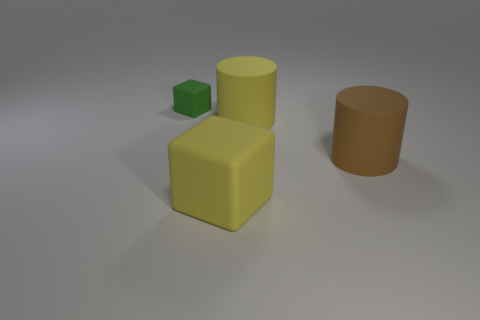Add 2 yellow cylinders. How many objects exist? 6 Subtract 2 blocks. How many blocks are left? 0 Subtract all green cubes. How many cubes are left? 1 Subtract 0 red blocks. How many objects are left? 4 Subtract all brown blocks. Subtract all yellow cylinders. How many blocks are left? 2 Subtract all brown blocks. How many green cylinders are left? 0 Subtract all large brown metal balls. Subtract all large yellow matte blocks. How many objects are left? 3 Add 3 yellow matte things. How many yellow matte things are left? 5 Add 4 tiny cyan rubber objects. How many tiny cyan rubber objects exist? 4 